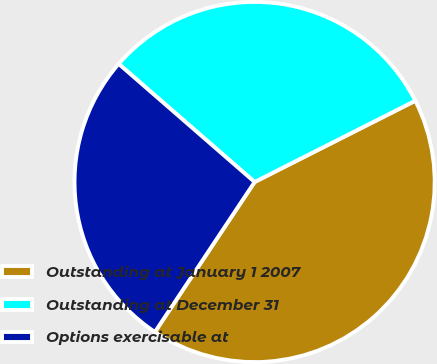Convert chart to OTSL. <chart><loc_0><loc_0><loc_500><loc_500><pie_chart><fcel>Outstanding at January 1 2007<fcel>Outstanding at December 31<fcel>Options exercisable at<nl><fcel>41.79%<fcel>31.16%<fcel>27.05%<nl></chart> 